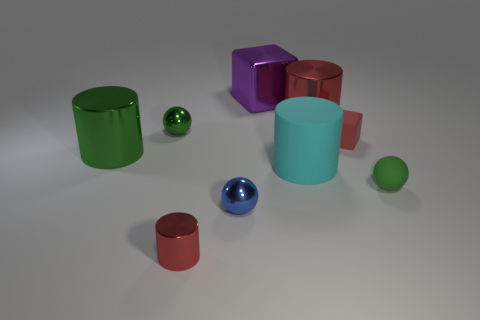What color is the cylinder on the right side of the large cyan cylinder?
Offer a terse response. Red. Does the block in front of the big shiny block have the same material as the big green thing?
Provide a short and direct response. No. What number of green spheres are in front of the large green metal object and left of the green rubber object?
Offer a very short reply. 0. What is the color of the large metallic object that is in front of the sphere that is behind the red cube that is in front of the big purple cube?
Provide a succinct answer. Green. How many other objects are the same shape as the purple metal object?
Your answer should be compact. 1. There is a green sphere left of the blue shiny sphere; are there any large cyan rubber objects to the left of it?
Your response must be concise. No. How many metal objects are cyan cylinders or small brown blocks?
Make the answer very short. 0. What material is the small thing that is in front of the large rubber thing and to the left of the blue object?
Keep it short and to the point. Metal. Is there a metallic ball right of the tiny metal sphere that is behind the blue ball that is on the left side of the small red matte object?
Provide a succinct answer. Yes. Is there anything else that has the same material as the large purple object?
Provide a short and direct response. Yes. 